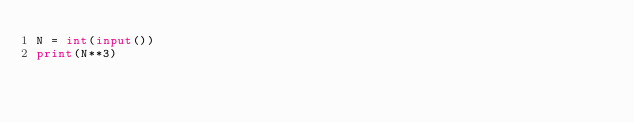Convert code to text. <code><loc_0><loc_0><loc_500><loc_500><_Python_>N = int(input())
print(N**3)</code> 